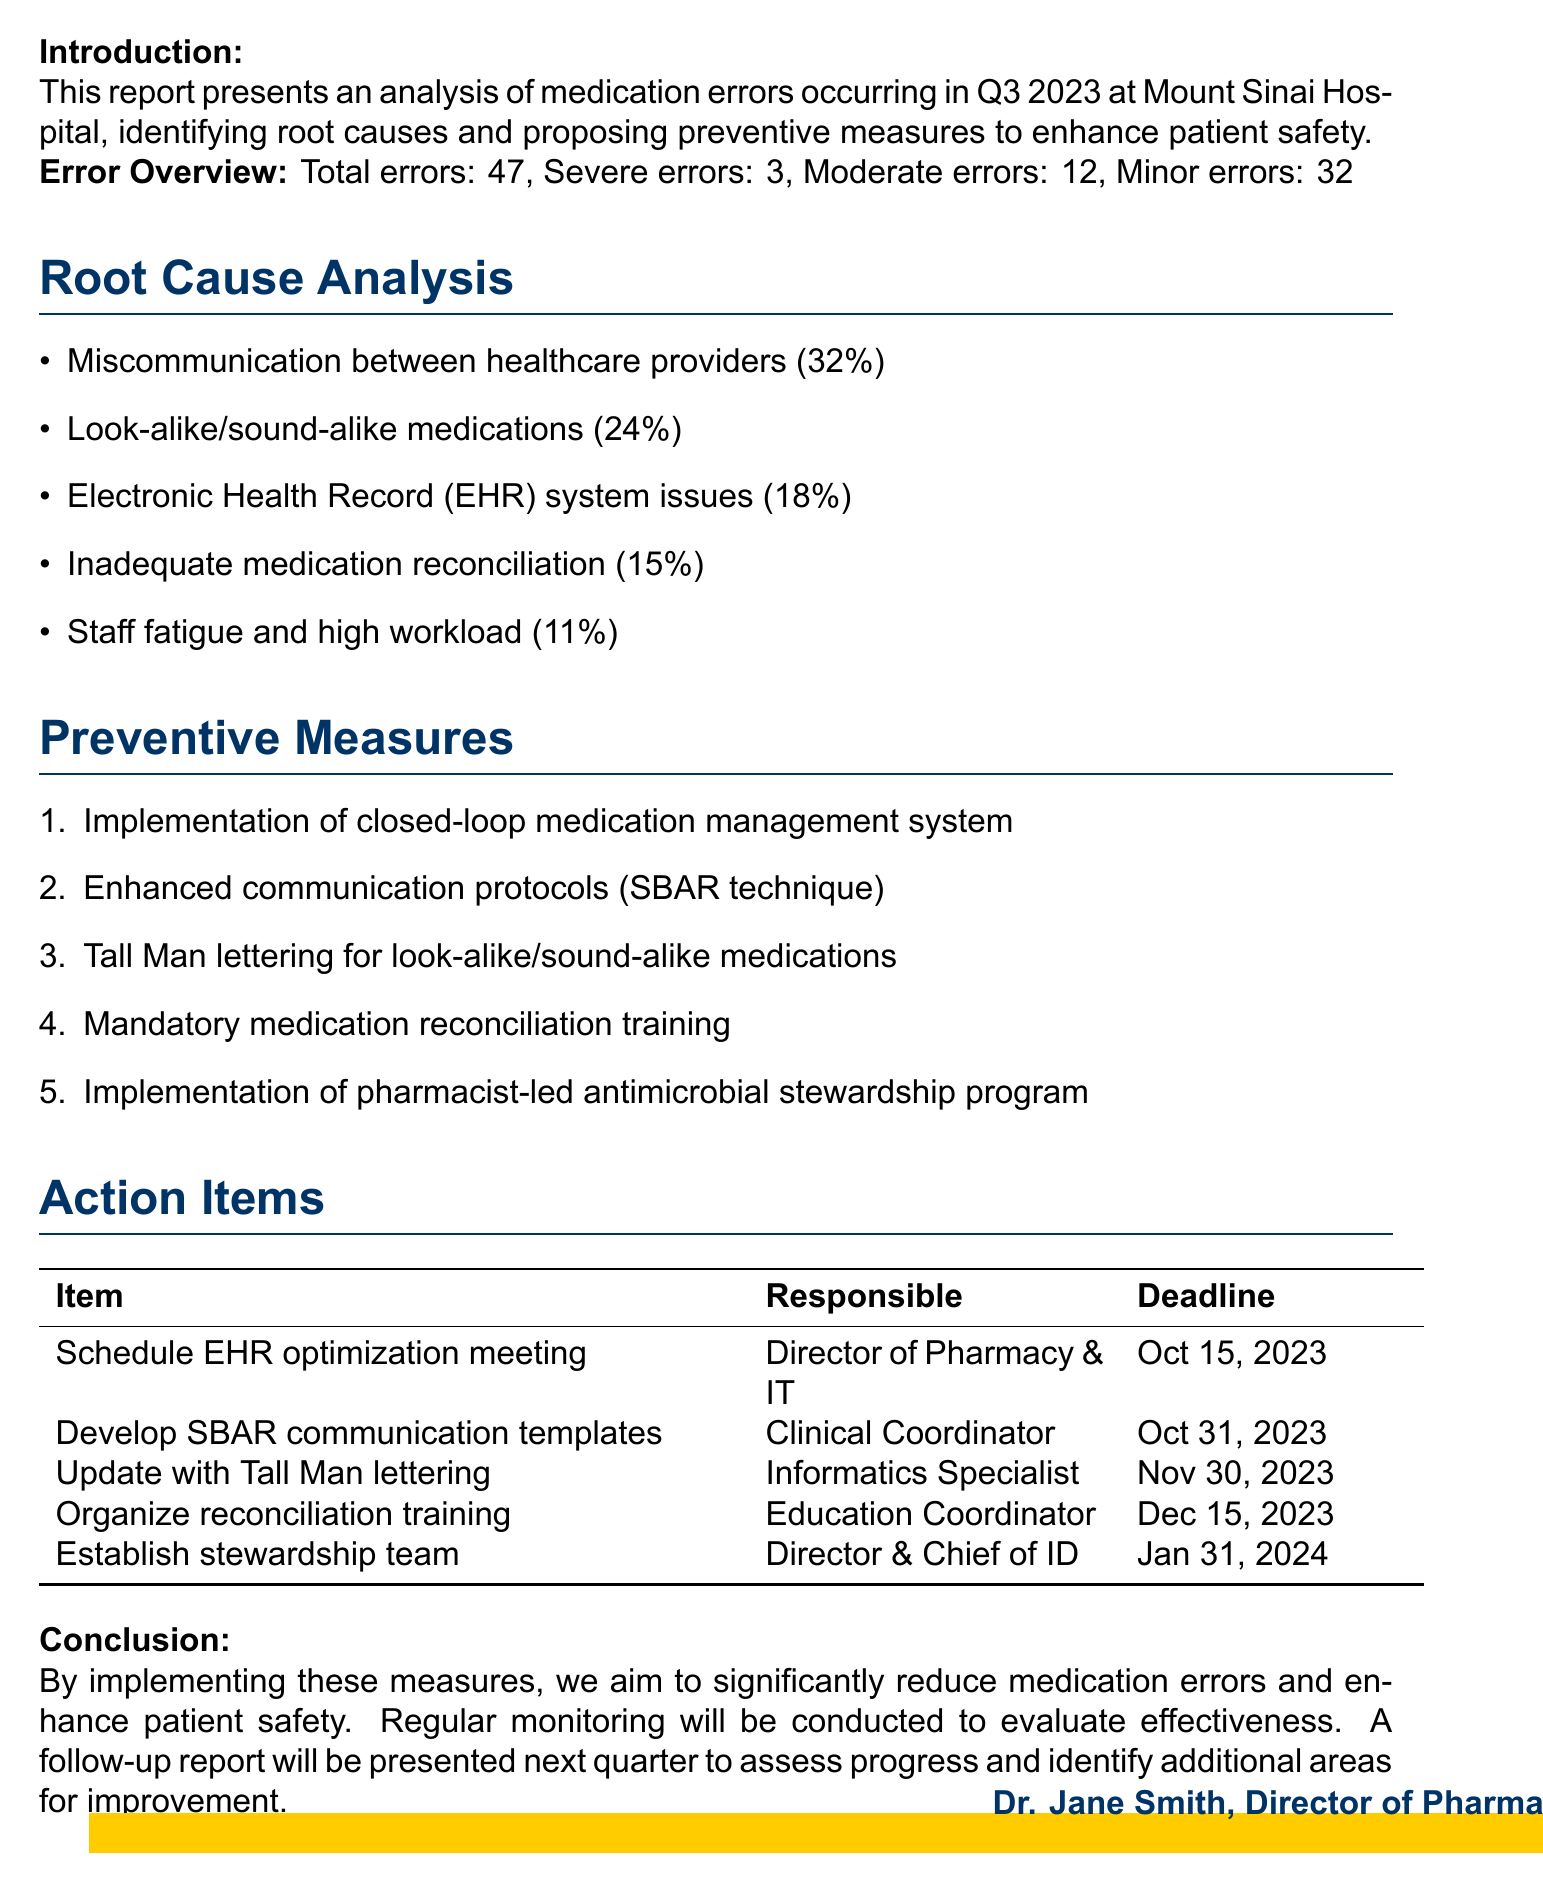what is the total number of medication errors reported? The total number of medication errors mentioned in the document is provided in the error overview section.
Answer: 47 how many severe medication errors were recorded? The number of severe medication errors is specified in the error overview section of the report.
Answer: 3 what percentage of errors were due to miscommunication between healthcare providers? The document lists the primary causes of medication errors along with their respective percentages.
Answer: 32% which preventive measure has an expected impact of reducing medication errors by 40%? The document mentions specific preventive measures and their expected impacts, which includes the closed-loop medication management system.
Answer: Implementation of closed-loop medication management system who is responsible for developing and distributing the SBAR communication templates? The document assigns responsibility for action items to specific roles within the organization.
Answer: Pharmacy Clinical Coordinator what is the deadline for organizing medication reconciliation training sessions? The deadline for each action item is listed in the action items section of the report.
Answer: December 15, 2023 which root cause analysis issue had the lowest percentage? The root causes of medication errors are provided with their respective percentages in the document.
Answer: Staff fatigue and high workload who will establish the antimicrobial stewardship team and protocols? The document indicates who is responsible for each action item, including the establishment of the stewardship team.
Answer: Director of Pharmacy and Chief of Infectious Diseases what conclusion does the report aim to achieve? The conclusion summarizes the goals of implementing the proposed measures discussed in the report.
Answer: Reduce medication errors and enhance patient safety 